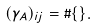Convert formula to latex. <formula><loc_0><loc_0><loc_500><loc_500>( \gamma _ { A } ) _ { i j } = \# \{ \} .</formula> 